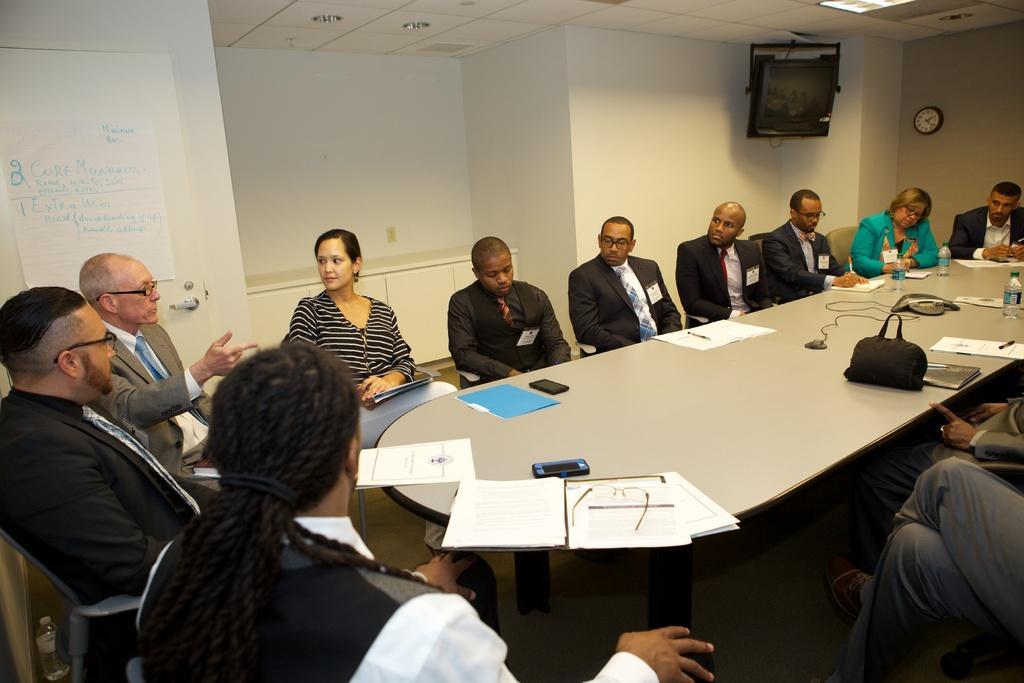Can you describe this image briefly? In this picture there is a woman who is wearing striped dress and white trouser. She is sitting on the chair. Beside her we can see old man who is wearing spectacle, suit and trouser. At the bottom there is another man who is sitting near to the table. On the table we can see the papers, files, mobile phones, bag, laptop, pen, water bottle, cables and other object. On the right there is another woman who is wearing green jacket. Beside her we can see group of persons. In the top right corner we can see the television and clock on the wall. In the background there is a projector screen near to the wall, beside that we can see the desk. in the top left we can see poster which is attached to the door. 